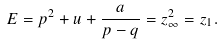Convert formula to latex. <formula><loc_0><loc_0><loc_500><loc_500>E = p ^ { 2 } + u + \frac { a } { p - q } = z _ { \infty } ^ { 2 } = z _ { 1 } .</formula> 